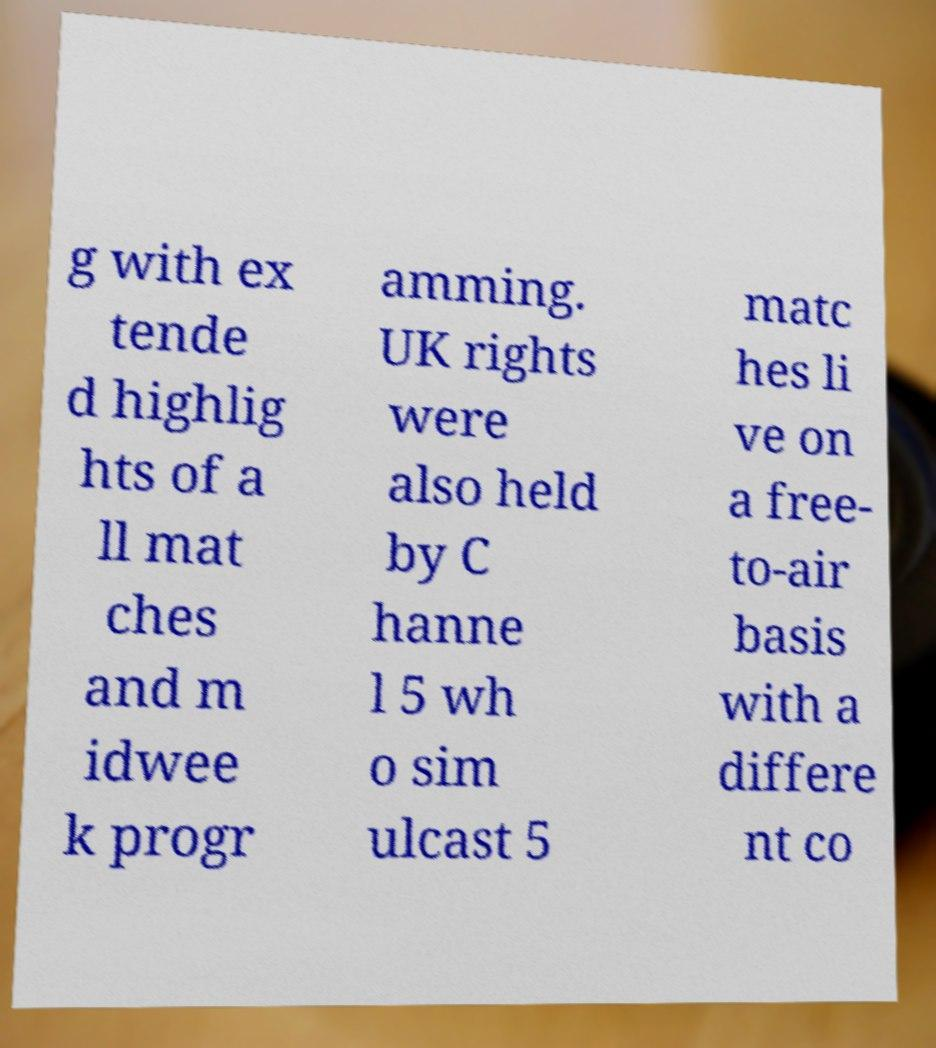I need the written content from this picture converted into text. Can you do that? g with ex tende d highlig hts of a ll mat ches and m idwee k progr amming. UK rights were also held by C hanne l 5 wh o sim ulcast 5 matc hes li ve on a free- to-air basis with a differe nt co 